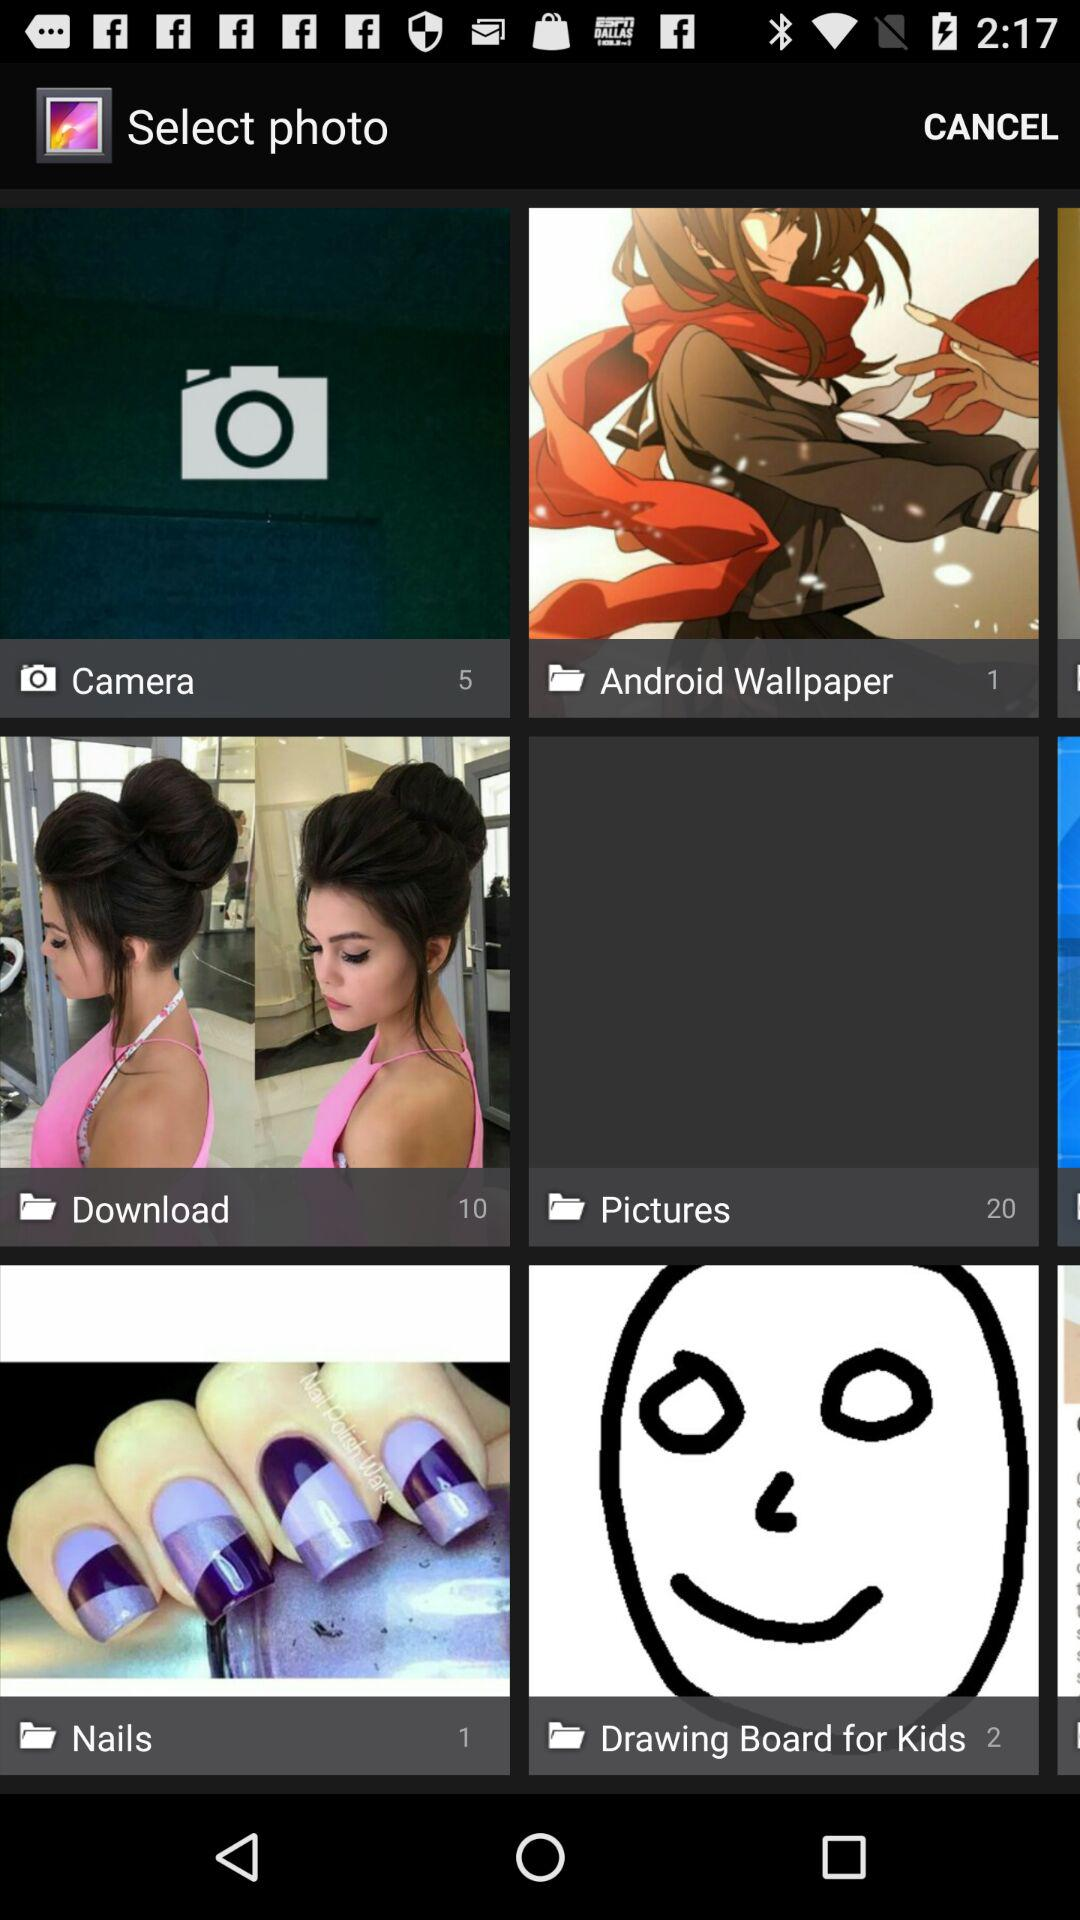How many photos are there in the "Camera" folder? There are 5 photos in the "Camera" folder. 